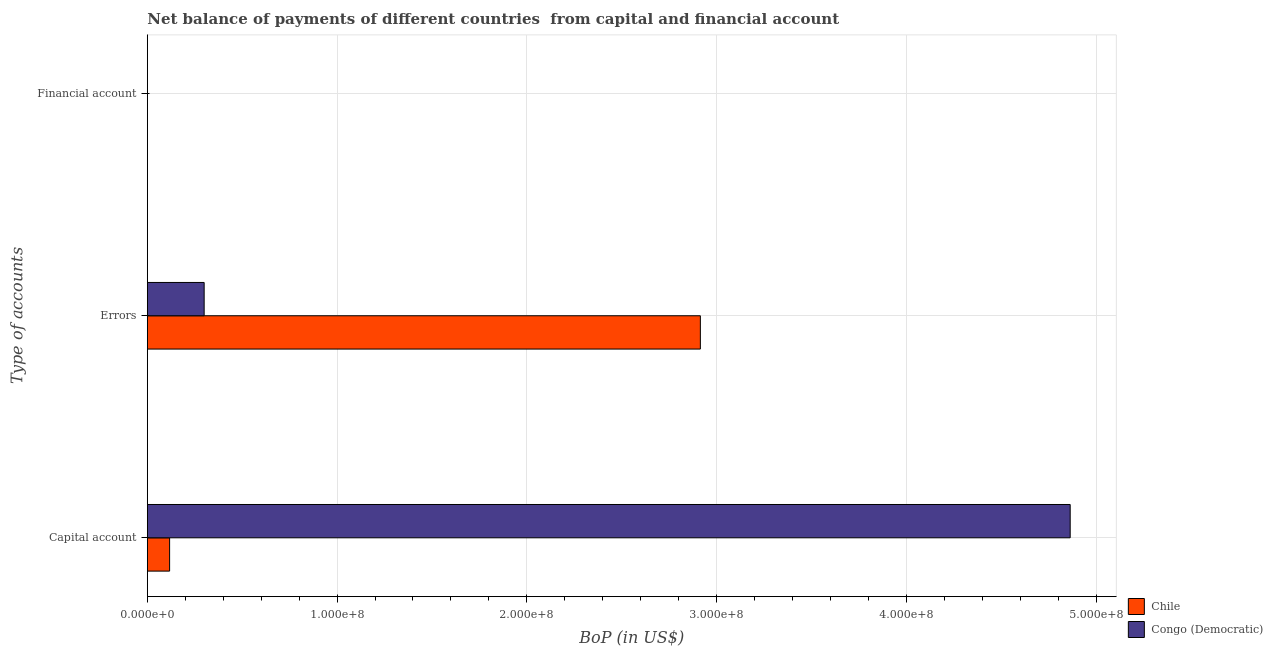How many different coloured bars are there?
Offer a very short reply. 2. Are the number of bars per tick equal to the number of legend labels?
Offer a very short reply. No. Are the number of bars on each tick of the Y-axis equal?
Your response must be concise. No. How many bars are there on the 1st tick from the top?
Ensure brevity in your answer.  0. How many bars are there on the 3rd tick from the bottom?
Offer a terse response. 0. What is the label of the 2nd group of bars from the top?
Your response must be concise. Errors. Across all countries, what is the maximum amount of errors?
Provide a succinct answer. 2.91e+08. Across all countries, what is the minimum amount of financial account?
Offer a terse response. 0. In which country was the amount of net capital account maximum?
Offer a very short reply. Congo (Democratic). What is the difference between the amount of errors in Congo (Democratic) and that in Chile?
Keep it short and to the point. -2.62e+08. What is the difference between the amount of errors in Congo (Democratic) and the amount of net capital account in Chile?
Offer a terse response. 1.82e+07. What is the average amount of errors per country?
Provide a succinct answer. 1.61e+08. What is the difference between the amount of errors and amount of net capital account in Chile?
Keep it short and to the point. 2.80e+08. What is the ratio of the amount of net capital account in Chile to that in Congo (Democratic)?
Your response must be concise. 0.02. Is the amount of net capital account in Congo (Democratic) less than that in Chile?
Offer a terse response. No. What is the difference between the highest and the second highest amount of errors?
Your answer should be very brief. 2.62e+08. What is the difference between the highest and the lowest amount of errors?
Offer a very short reply. 2.62e+08. Is the sum of the amount of errors in Chile and Congo (Democratic) greater than the maximum amount of financial account across all countries?
Provide a short and direct response. Yes. Is it the case that in every country, the sum of the amount of net capital account and amount of errors is greater than the amount of financial account?
Make the answer very short. Yes. How many bars are there?
Make the answer very short. 4. What is the difference between two consecutive major ticks on the X-axis?
Ensure brevity in your answer.  1.00e+08. Does the graph contain any zero values?
Offer a terse response. Yes. Where does the legend appear in the graph?
Your answer should be compact. Bottom right. How are the legend labels stacked?
Provide a succinct answer. Vertical. What is the title of the graph?
Your answer should be very brief. Net balance of payments of different countries  from capital and financial account. Does "OECD members" appear as one of the legend labels in the graph?
Provide a short and direct response. No. What is the label or title of the X-axis?
Your response must be concise. BoP (in US$). What is the label or title of the Y-axis?
Your answer should be very brief. Type of accounts. What is the BoP (in US$) of Chile in Capital account?
Offer a very short reply. 1.17e+07. What is the BoP (in US$) in Congo (Democratic) in Capital account?
Your answer should be very brief. 4.86e+08. What is the BoP (in US$) in Chile in Errors?
Ensure brevity in your answer.  2.91e+08. What is the BoP (in US$) of Congo (Democratic) in Errors?
Offer a terse response. 2.99e+07. Across all Type of accounts, what is the maximum BoP (in US$) of Chile?
Your answer should be compact. 2.91e+08. Across all Type of accounts, what is the maximum BoP (in US$) in Congo (Democratic)?
Your response must be concise. 4.86e+08. Across all Type of accounts, what is the minimum BoP (in US$) of Chile?
Make the answer very short. 0. What is the total BoP (in US$) of Chile in the graph?
Offer a terse response. 3.03e+08. What is the total BoP (in US$) of Congo (Democratic) in the graph?
Provide a succinct answer. 5.16e+08. What is the difference between the BoP (in US$) of Chile in Capital account and that in Errors?
Offer a very short reply. -2.80e+08. What is the difference between the BoP (in US$) of Congo (Democratic) in Capital account and that in Errors?
Offer a very short reply. 4.56e+08. What is the difference between the BoP (in US$) of Chile in Capital account and the BoP (in US$) of Congo (Democratic) in Errors?
Your answer should be very brief. -1.82e+07. What is the average BoP (in US$) in Chile per Type of accounts?
Offer a very short reply. 1.01e+08. What is the average BoP (in US$) of Congo (Democratic) per Type of accounts?
Give a very brief answer. 1.72e+08. What is the difference between the BoP (in US$) in Chile and BoP (in US$) in Congo (Democratic) in Capital account?
Provide a short and direct response. -4.75e+08. What is the difference between the BoP (in US$) in Chile and BoP (in US$) in Congo (Democratic) in Errors?
Your response must be concise. 2.62e+08. What is the ratio of the BoP (in US$) in Chile in Capital account to that in Errors?
Your answer should be compact. 0.04. What is the ratio of the BoP (in US$) in Congo (Democratic) in Capital account to that in Errors?
Keep it short and to the point. 16.24. What is the difference between the highest and the lowest BoP (in US$) of Chile?
Your response must be concise. 2.91e+08. What is the difference between the highest and the lowest BoP (in US$) in Congo (Democratic)?
Your answer should be compact. 4.86e+08. 